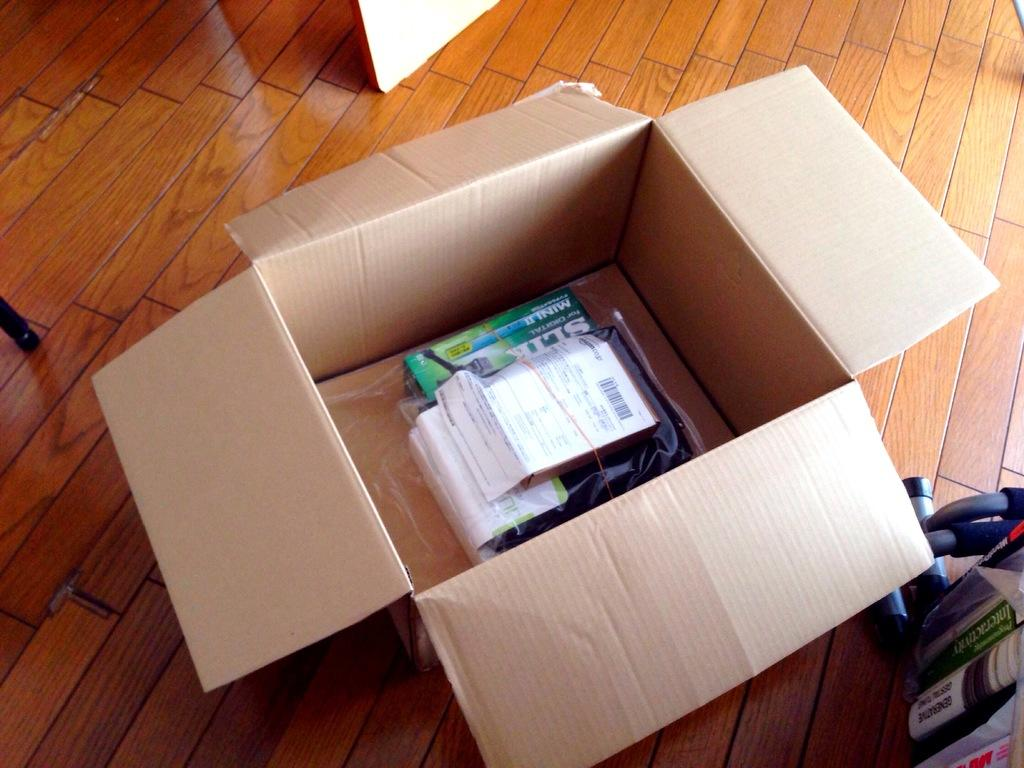What is inside the cardboard box in the image? The contents of the cardboard box are not visible, but there are objects inside the box. What is the surface beneath the cardboard box? The cardboard box is on a brown color surface. What can be seen to the right of the cardboard box? There are books to the right of the box. How many cows are visible in the image? There are no cows present in the image. What type of string is being used to hold the books together? There is no string visible in the image, and the books are not being held together. 